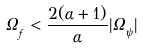<formula> <loc_0><loc_0><loc_500><loc_500>\Omega _ { _ { f } } < \frac { 2 ( \alpha + 1 ) } { \alpha } | \Omega _ { _ { \psi } } |</formula> 